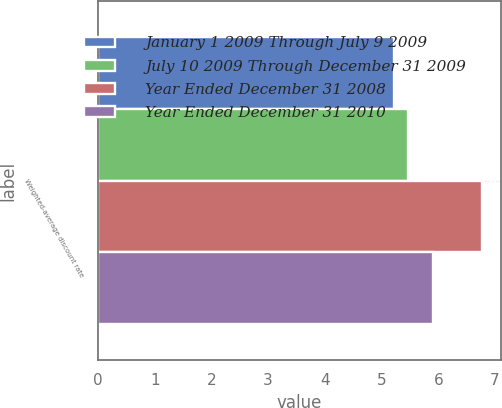Convert chart to OTSL. <chart><loc_0><loc_0><loc_500><loc_500><stacked_bar_chart><ecel><fcel>Weighted-average discount rate<nl><fcel>January 1 2009 Through July 9 2009<fcel>5.22<nl><fcel>July 10 2009 Through December 31 2009<fcel>5.47<nl><fcel>Year Ended December 31 2008<fcel>6.77<nl><fcel>Year Ended December 31 2010<fcel>5.9<nl></chart> 